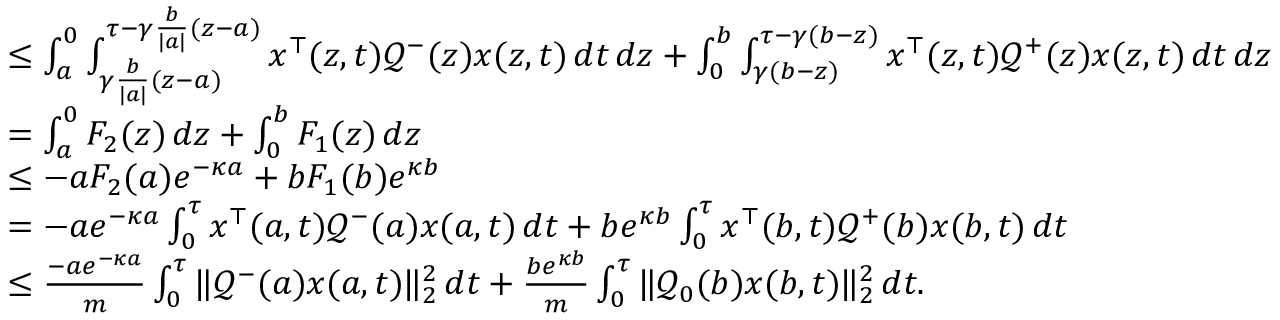Convert formula to latex. <formula><loc_0><loc_0><loc_500><loc_500>\begin{array} { r l } & { \leq \int _ { a } ^ { 0 } \int _ { \gamma \frac { b } { | a | } ( z - a ) } ^ { \tau - \gamma \frac { b } { | a | } ( z - a ) } x ^ { \top } ( z , t ) \mathcal { Q } ^ { - } ( z ) x ( z , t ) \, d t \, d z + \int _ { 0 } ^ { b } \int _ { \gamma ( b - z ) } ^ { \tau - \gamma ( b - z ) } x ^ { \top } ( z , t ) \mathcal { Q } ^ { + } ( z ) x ( z , t ) \, d t \, d z } \\ & { = \int _ { a } ^ { 0 } F _ { 2 } ( z ) \, d z + \int _ { 0 } ^ { b } F _ { 1 } ( z ) \, d z } \\ & { \leq - a F _ { 2 } ( a ) e ^ { - \kappa a } + b F _ { 1 } ( b ) e ^ { \kappa b } } \\ & { = - a e ^ { - \kappa a } \int _ { 0 } ^ { \tau } x ^ { \top } ( a , t ) \mathcal { Q } ^ { - } ( a ) x ( a , t ) \, d t + b e ^ { \kappa b } \int _ { 0 } ^ { \tau } x ^ { \top } ( b , t ) \mathcal { Q } ^ { + } ( b ) x ( b , t ) \, d t } \\ & { \leq \frac { - a e ^ { - \kappa a } } { m } \int _ { 0 } ^ { \tau } \| \mathcal { Q } ^ { - } ( a ) x ( a , t ) \| _ { 2 } ^ { 2 } \, d t + \frac { b e ^ { \kappa b } } { m } \int _ { 0 } ^ { \tau } \| \mathcal { Q } _ { 0 } ( b ) x ( b , t ) \| _ { 2 } ^ { 2 } \, d t . } \end{array}</formula> 